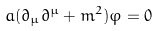Convert formula to latex. <formula><loc_0><loc_0><loc_500><loc_500>a ( \partial _ { \mu } \partial ^ { \mu } + m ^ { 2 } ) \varphi = 0</formula> 